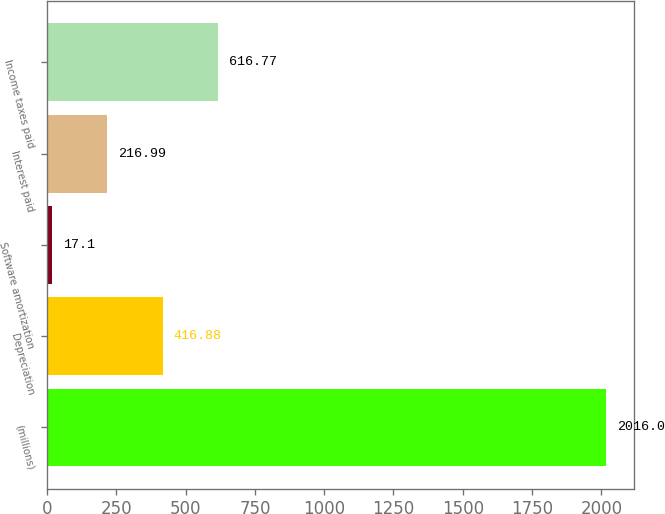Convert chart. <chart><loc_0><loc_0><loc_500><loc_500><bar_chart><fcel>(millions)<fcel>Depreciation<fcel>Software amortization<fcel>Interest paid<fcel>Income taxes paid<nl><fcel>2016<fcel>416.88<fcel>17.1<fcel>216.99<fcel>616.77<nl></chart> 